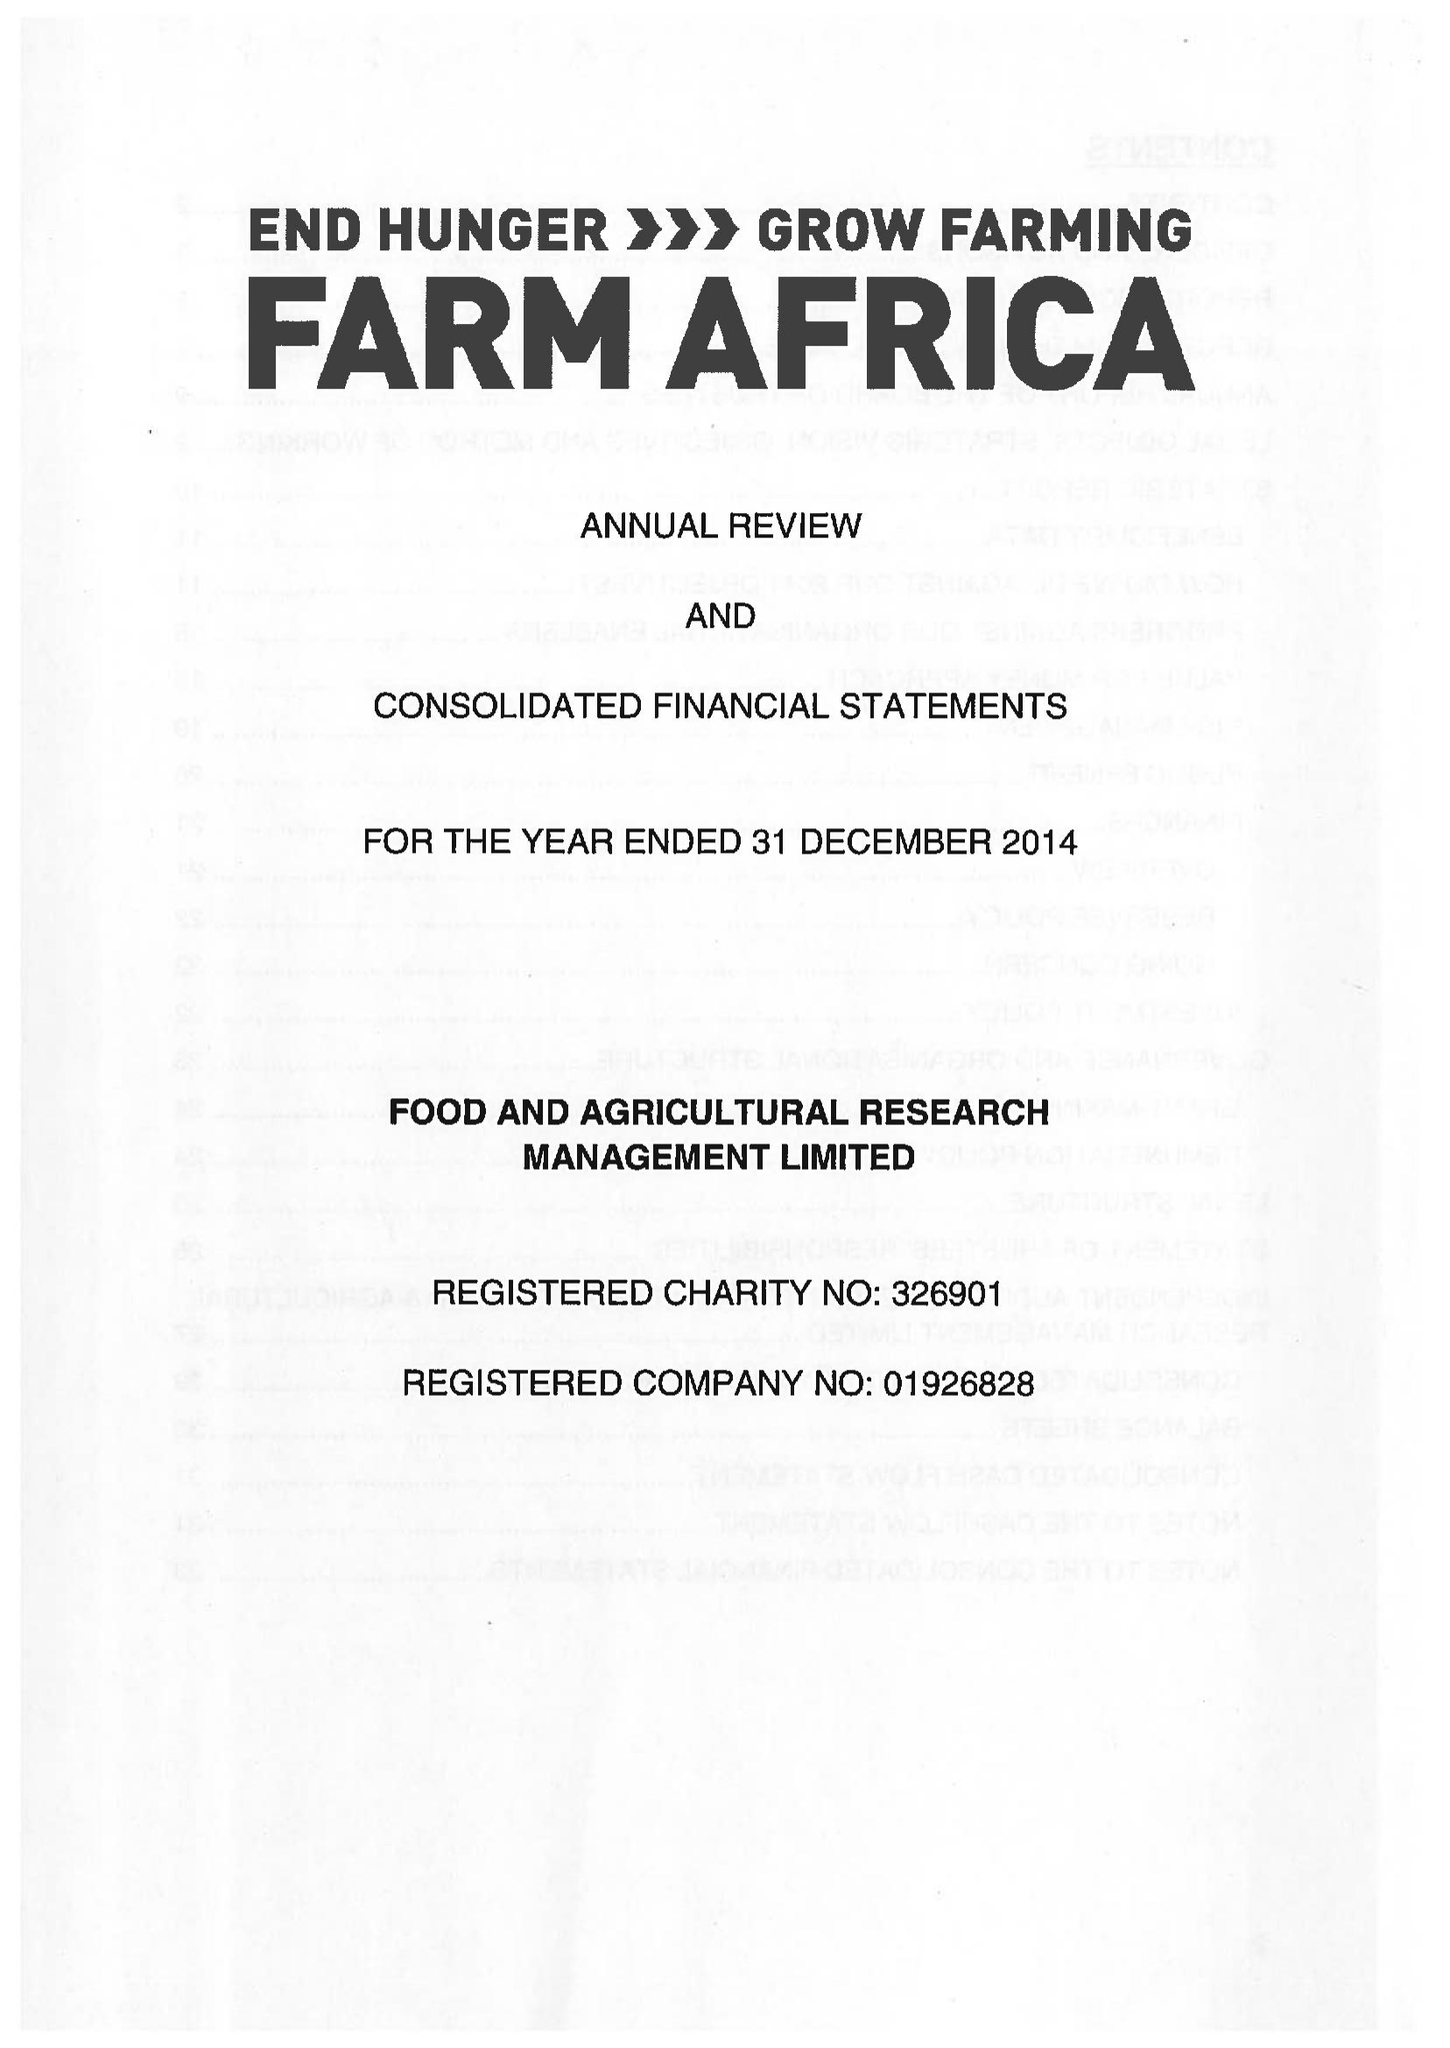What is the value for the report_date?
Answer the question using a single word or phrase. 2014-12-31 